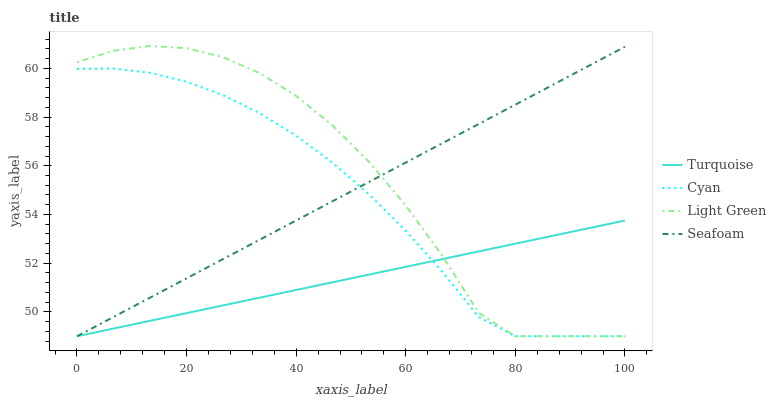Does Turquoise have the minimum area under the curve?
Answer yes or no. Yes. Does Light Green have the maximum area under the curve?
Answer yes or no. Yes. Does Seafoam have the minimum area under the curve?
Answer yes or no. No. Does Seafoam have the maximum area under the curve?
Answer yes or no. No. Is Turquoise the smoothest?
Answer yes or no. Yes. Is Light Green the roughest?
Answer yes or no. Yes. Is Seafoam the smoothest?
Answer yes or no. No. Is Seafoam the roughest?
Answer yes or no. No. Does Light Green have the highest value?
Answer yes or no. Yes. Does Seafoam have the highest value?
Answer yes or no. No. 